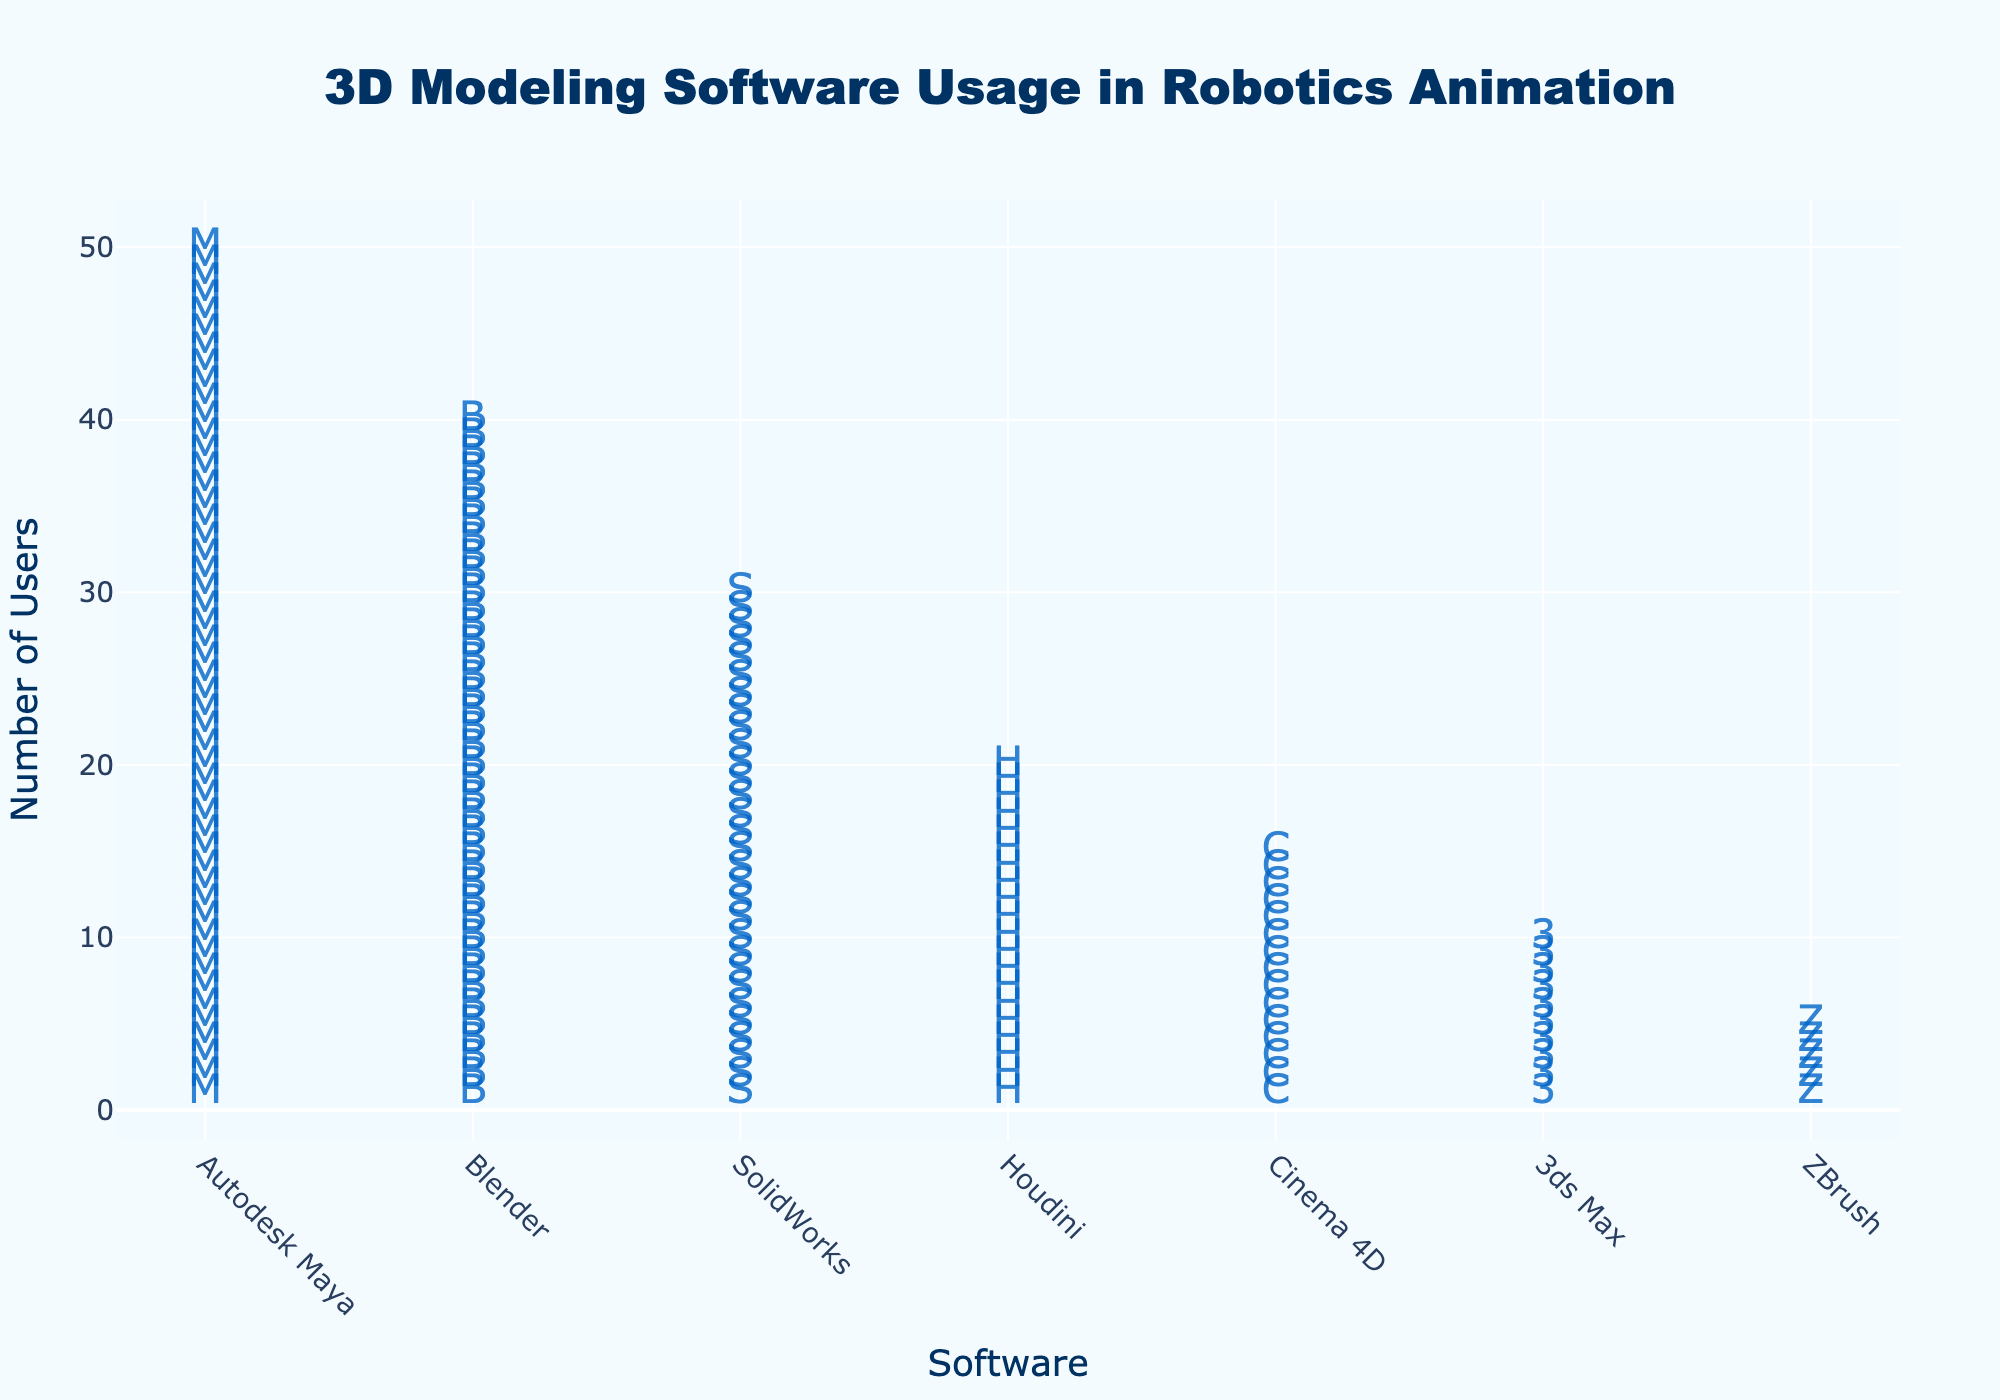which software has the highest number of users? By looking at the figure, identify which software has the most icons displayed. According to the data, "Autodesk Maya" has the highest number of users, represented by the most icons.
Answer: Autodesk Maya how many users in total use Blender and Houdini combined? To find the total number of users for Blender and Houdini, add the users for each software. Blender has 40 users, and Houdini has 20 users. 40 + 20 = 60
Answer: 60 which software is used by fewer users, Cinema 4D or 3ds Max? Compare the number of users represented by icons for Cinema 4D and 3ds Max. Cinema 4D has 15 users, while 3ds Max has 10 users. Therefore, 3ds Max is used by fewer users.
Answer: 3ds Max what's the difference in the number of users between SolidWorks and ZBrush? To find the difference, subtract the number of users of ZBrush from SolidWorks. SolidWorks has 30 users, and ZBrush has 5 users. 30 - 5 = 25
Answer: 25 are there more users using Blender compared to the combined users of Cinema 4D and ZBrush? Calculate the combined users of Cinema 4D and ZBrush: 15 + 5 = 20. Compare this with the number of Blender users which is 40. Since 40 > 20, more users are using Blender.
Answer: Yes what is the total number of users for all 3D modeling software listed? Sum the number of users for all software: 50 (Autodesk Maya) + 40 (Blender) + 30 (SolidWorks) + 20 (Houdini) + 15 (Cinema 4D) + 10 (3ds Max) + 5 (ZBrush). This gives a total of 170.
Answer: 170 which software has more users, Houdini or SolidWorks? Compare the number of users represented by icons for Houdini and SolidWorks. Houdini has 20 users and SolidWorks has 30 users. Therefore, SolidWorks has more users.
Answer: SolidWorks how many more users does Autodesk Maya have than 3ds Max? Subtract the number of users of 3ds Max from Autodesk Maya. Autodesk Maya has 50 users, and 3ds Max has 10 users. 50 - 10 = 40
Answer: 40 what is the difference in the number of users between the software with the highest and lowest user counts? Identify the software with the highest user count (Autodesk Maya with 50 users) and the lowest user count (ZBrush with 5 users). Then subtract the smallest from the largest: 50 - 5 = 45
Answer: 45 